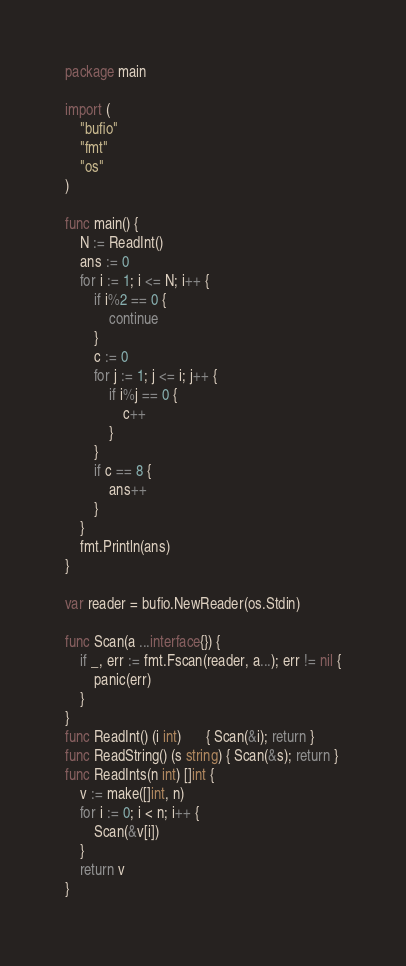<code> <loc_0><loc_0><loc_500><loc_500><_Go_>package main

import (
	"bufio"
	"fmt"
	"os"
)

func main() {
	N := ReadInt()
	ans := 0
	for i := 1; i <= N; i++ {
		if i%2 == 0 {
			continue
		}
		c := 0
		for j := 1; j <= i; j++ {
			if i%j == 0 {
				c++
			}
		}
		if c == 8 {
			ans++
		}
	}
	fmt.Println(ans)
}

var reader = bufio.NewReader(os.Stdin)

func Scan(a ...interface{}) {
	if _, err := fmt.Fscan(reader, a...); err != nil {
		panic(err)
	}
}
func ReadInt() (i int)       { Scan(&i); return }
func ReadString() (s string) { Scan(&s); return }
func ReadInts(n int) []int {
	v := make([]int, n)
	for i := 0; i < n; i++ {
		Scan(&v[i])
	}
	return v
}
</code> 